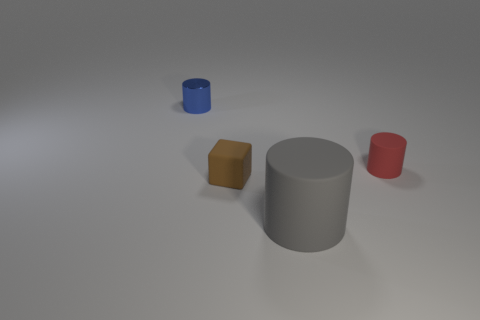What size is the matte object that is both in front of the small red cylinder and right of the tiny cube?
Your response must be concise. Large. What is the size of the gray object that is the same shape as the blue metallic object?
Keep it short and to the point. Large. There is a gray rubber object; are there any red cylinders behind it?
Give a very brief answer. Yes. What is the material of the large object?
Provide a succinct answer. Rubber. Is there anything else that is the same shape as the small brown thing?
Offer a very short reply. No. What color is the other small thing that is the same shape as the tiny red object?
Offer a very short reply. Blue. What is the object on the left side of the tiny brown block made of?
Your answer should be very brief. Metal. What is the color of the matte block?
Your response must be concise. Brown. There is a thing to the right of the gray cylinder; does it have the same size as the blue metallic object?
Provide a short and direct response. Yes. There is a object that is behind the small cylinder that is to the right of the metal cylinder that is behind the tiny brown matte cube; what is its material?
Give a very brief answer. Metal. 